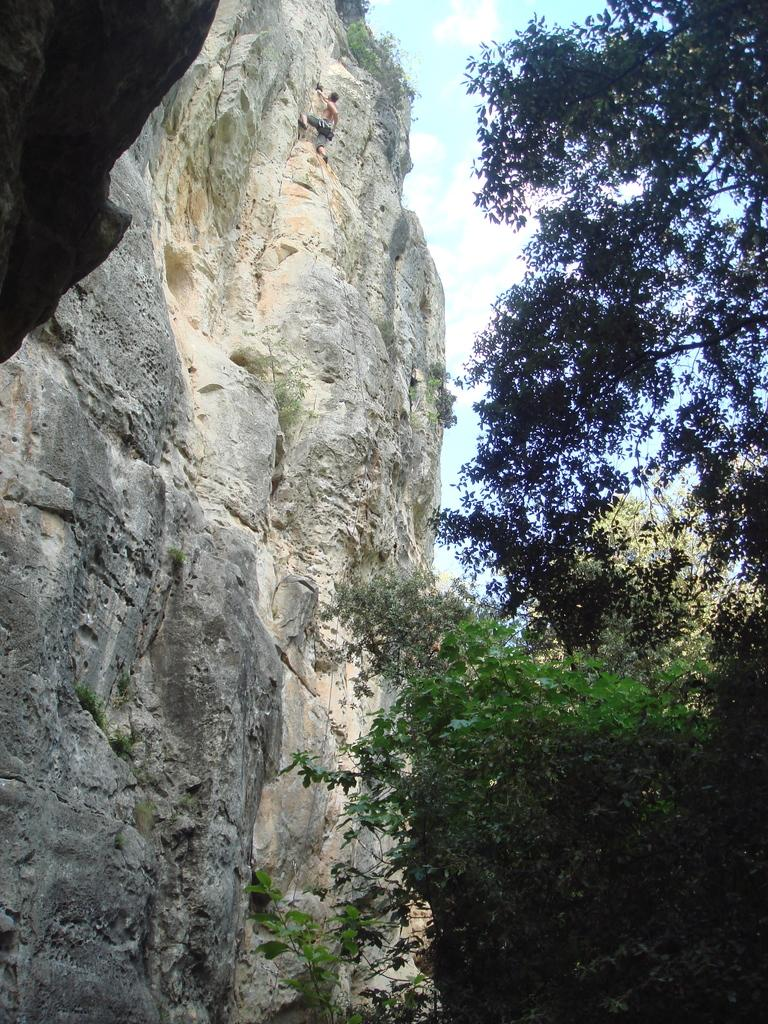What type of natural elements can be seen in the image? There are trees and a mountain in the image. What part of the natural environment is visible in the image? The sky is visible in the image. What activity is the person in the image engaged in? The person is climbing the mountain in the image. What color is the crayon being used to draw on the protest sign in the image? There is no crayon or protest sign present in the image. What type of chalk is being used to write on the sidewalk in the image? There is no chalk or sidewalk present in the image. 